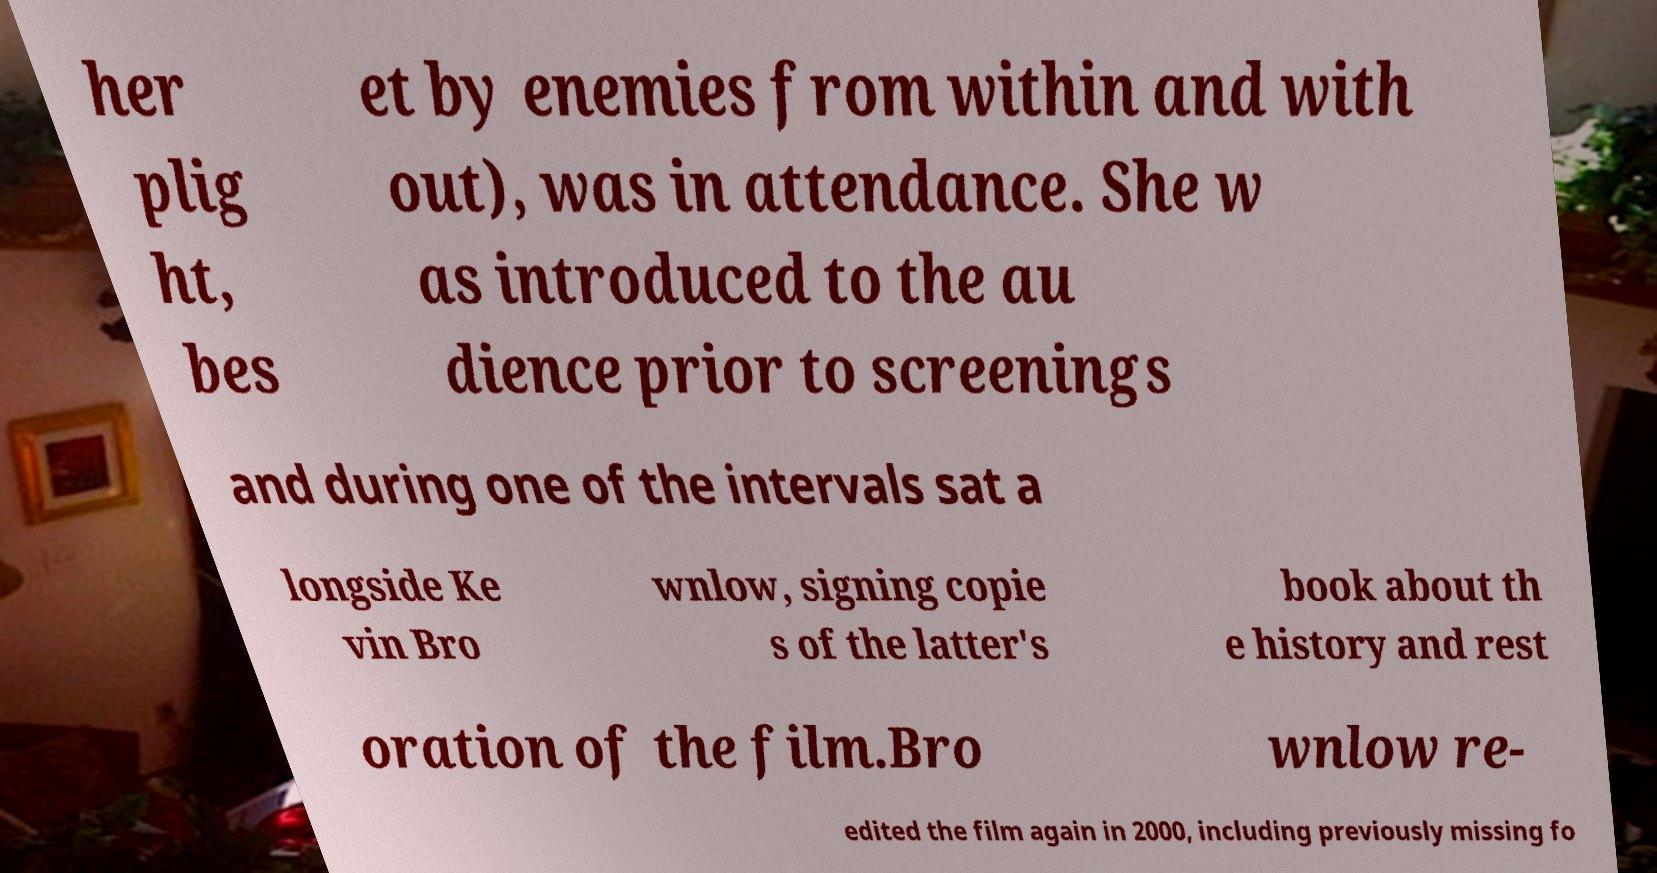Could you extract and type out the text from this image? her plig ht, bes et by enemies from within and with out), was in attendance. She w as introduced to the au dience prior to screenings and during one of the intervals sat a longside Ke vin Bro wnlow, signing copie s of the latter's book about th e history and rest oration of the film.Bro wnlow re- edited the film again in 2000, including previously missing fo 